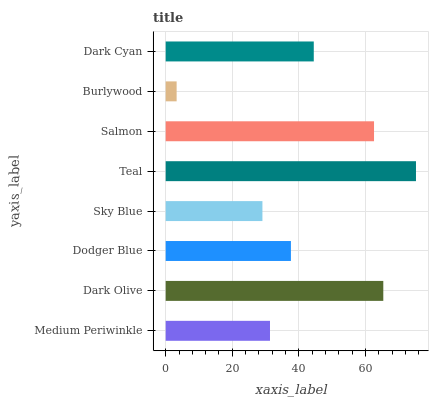Is Burlywood the minimum?
Answer yes or no. Yes. Is Teal the maximum?
Answer yes or no. Yes. Is Dark Olive the minimum?
Answer yes or no. No. Is Dark Olive the maximum?
Answer yes or no. No. Is Dark Olive greater than Medium Periwinkle?
Answer yes or no. Yes. Is Medium Periwinkle less than Dark Olive?
Answer yes or no. Yes. Is Medium Periwinkle greater than Dark Olive?
Answer yes or no. No. Is Dark Olive less than Medium Periwinkle?
Answer yes or no. No. Is Dark Cyan the high median?
Answer yes or no. Yes. Is Dodger Blue the low median?
Answer yes or no. Yes. Is Sky Blue the high median?
Answer yes or no. No. Is Teal the low median?
Answer yes or no. No. 